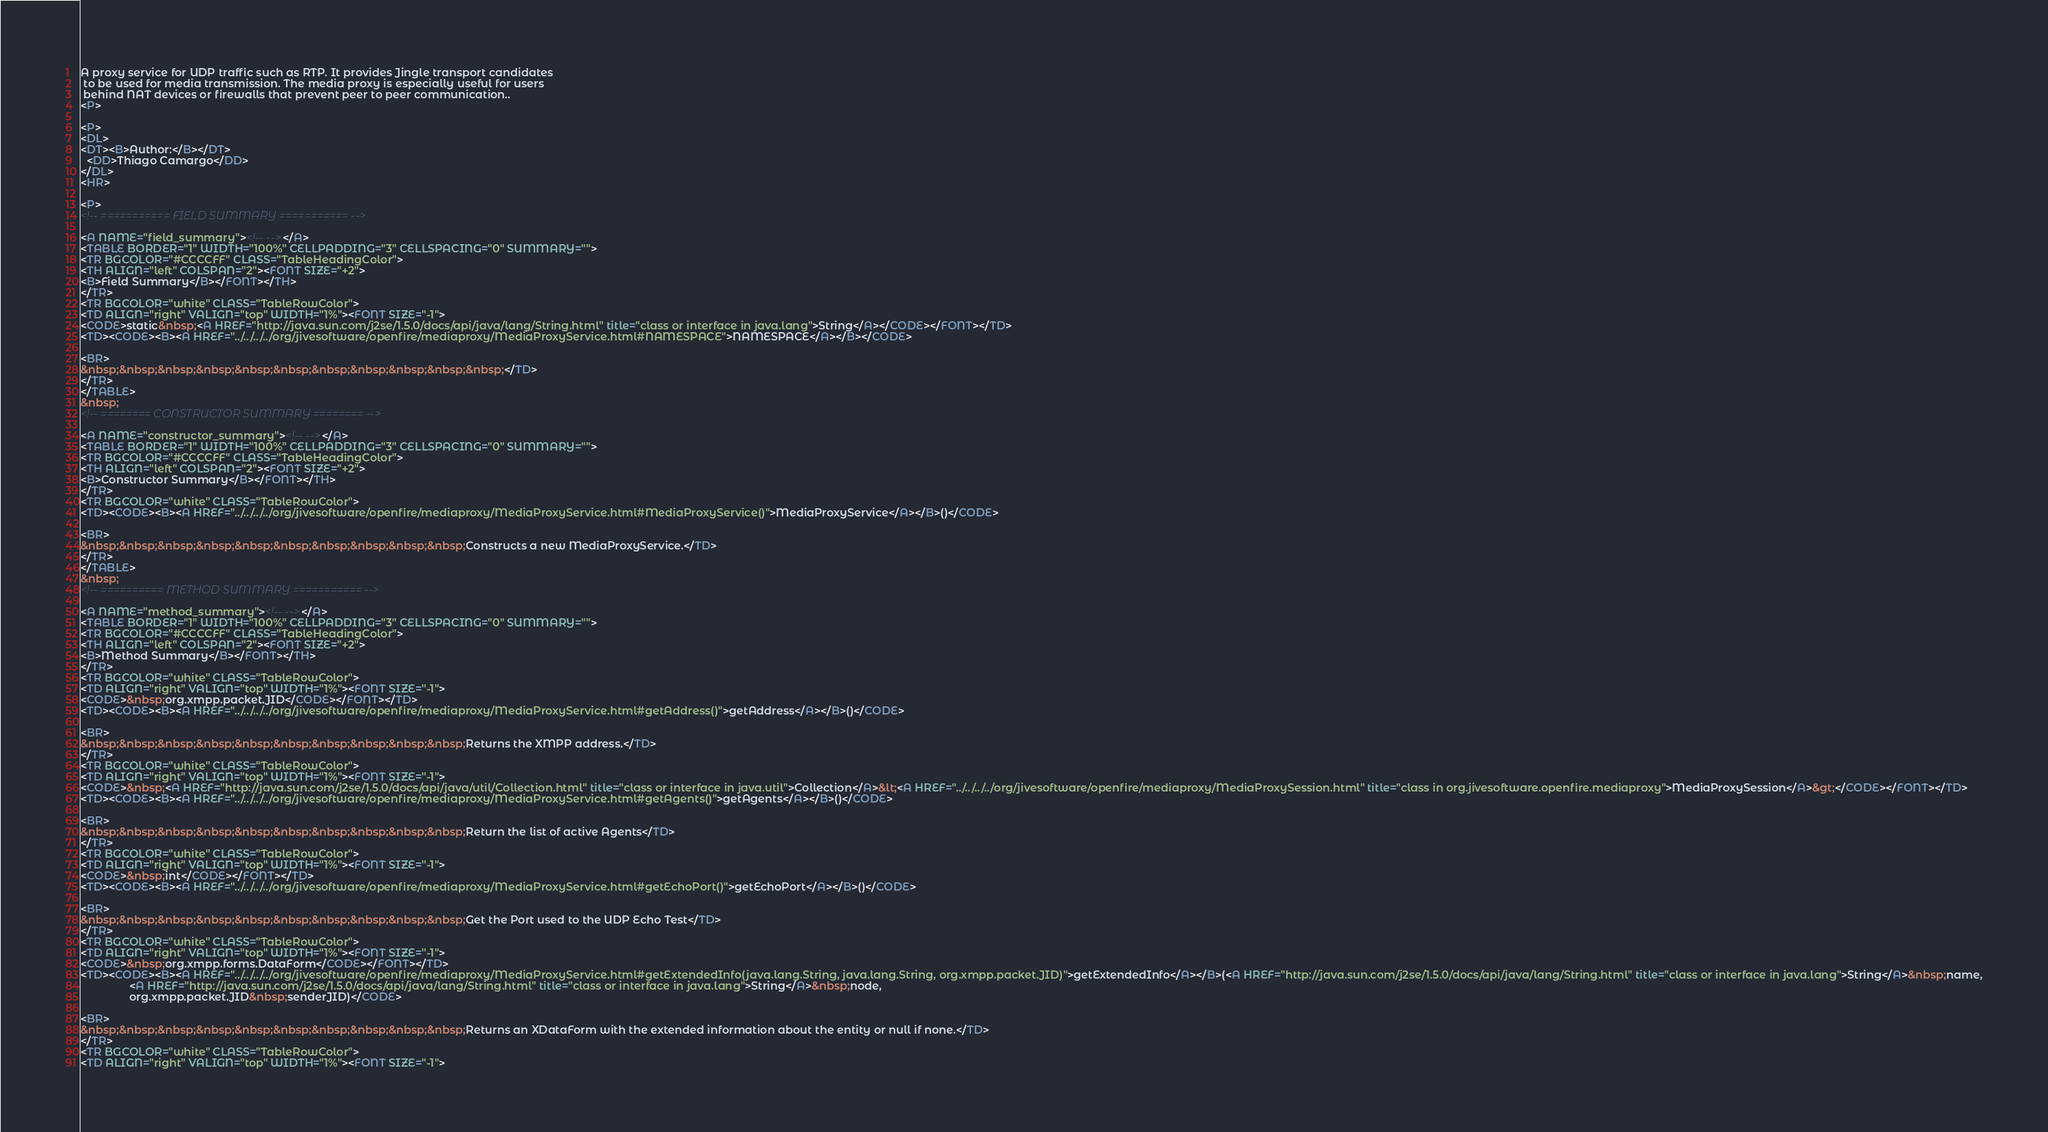Convert code to text. <code><loc_0><loc_0><loc_500><loc_500><_HTML_>A proxy service for UDP traffic such as RTP. It provides Jingle transport candidates
 to be used for media transmission. The media proxy is especially useful for users
 behind NAT devices or firewalls that prevent peer to peer communication..
<P>

<P>
<DL>
<DT><B>Author:</B></DT>
  <DD>Thiago Camargo</DD>
</DL>
<HR>

<P>
<!-- =========== FIELD SUMMARY =========== -->

<A NAME="field_summary"><!-- --></A>
<TABLE BORDER="1" WIDTH="100%" CELLPADDING="3" CELLSPACING="0" SUMMARY="">
<TR BGCOLOR="#CCCCFF" CLASS="TableHeadingColor">
<TH ALIGN="left" COLSPAN="2"><FONT SIZE="+2">
<B>Field Summary</B></FONT></TH>
</TR>
<TR BGCOLOR="white" CLASS="TableRowColor">
<TD ALIGN="right" VALIGN="top" WIDTH="1%"><FONT SIZE="-1">
<CODE>static&nbsp;<A HREF="http://java.sun.com/j2se/1.5.0/docs/api/java/lang/String.html" title="class or interface in java.lang">String</A></CODE></FONT></TD>
<TD><CODE><B><A HREF="../../../../org/jivesoftware/openfire/mediaproxy/MediaProxyService.html#NAMESPACE">NAMESPACE</A></B></CODE>

<BR>
&nbsp;&nbsp;&nbsp;&nbsp;&nbsp;&nbsp;&nbsp;&nbsp;&nbsp;&nbsp;&nbsp;</TD>
</TR>
</TABLE>
&nbsp;
<!-- ======== CONSTRUCTOR SUMMARY ======== -->

<A NAME="constructor_summary"><!-- --></A>
<TABLE BORDER="1" WIDTH="100%" CELLPADDING="3" CELLSPACING="0" SUMMARY="">
<TR BGCOLOR="#CCCCFF" CLASS="TableHeadingColor">
<TH ALIGN="left" COLSPAN="2"><FONT SIZE="+2">
<B>Constructor Summary</B></FONT></TH>
</TR>
<TR BGCOLOR="white" CLASS="TableRowColor">
<TD><CODE><B><A HREF="../../../../org/jivesoftware/openfire/mediaproxy/MediaProxyService.html#MediaProxyService()">MediaProxyService</A></B>()</CODE>

<BR>
&nbsp;&nbsp;&nbsp;&nbsp;&nbsp;&nbsp;&nbsp;&nbsp;&nbsp;&nbsp;Constructs a new MediaProxyService.</TD>
</TR>
</TABLE>
&nbsp;
<!-- ========== METHOD SUMMARY =========== -->

<A NAME="method_summary"><!-- --></A>
<TABLE BORDER="1" WIDTH="100%" CELLPADDING="3" CELLSPACING="0" SUMMARY="">
<TR BGCOLOR="#CCCCFF" CLASS="TableHeadingColor">
<TH ALIGN="left" COLSPAN="2"><FONT SIZE="+2">
<B>Method Summary</B></FONT></TH>
</TR>
<TR BGCOLOR="white" CLASS="TableRowColor">
<TD ALIGN="right" VALIGN="top" WIDTH="1%"><FONT SIZE="-1">
<CODE>&nbsp;org.xmpp.packet.JID</CODE></FONT></TD>
<TD><CODE><B><A HREF="../../../../org/jivesoftware/openfire/mediaproxy/MediaProxyService.html#getAddress()">getAddress</A></B>()</CODE>

<BR>
&nbsp;&nbsp;&nbsp;&nbsp;&nbsp;&nbsp;&nbsp;&nbsp;&nbsp;&nbsp;Returns the XMPP address.</TD>
</TR>
<TR BGCOLOR="white" CLASS="TableRowColor">
<TD ALIGN="right" VALIGN="top" WIDTH="1%"><FONT SIZE="-1">
<CODE>&nbsp;<A HREF="http://java.sun.com/j2se/1.5.0/docs/api/java/util/Collection.html" title="class or interface in java.util">Collection</A>&lt;<A HREF="../../../../org/jivesoftware/openfire/mediaproxy/MediaProxySession.html" title="class in org.jivesoftware.openfire.mediaproxy">MediaProxySession</A>&gt;</CODE></FONT></TD>
<TD><CODE><B><A HREF="../../../../org/jivesoftware/openfire/mediaproxy/MediaProxyService.html#getAgents()">getAgents</A></B>()</CODE>

<BR>
&nbsp;&nbsp;&nbsp;&nbsp;&nbsp;&nbsp;&nbsp;&nbsp;&nbsp;&nbsp;Return the list of active Agents</TD>
</TR>
<TR BGCOLOR="white" CLASS="TableRowColor">
<TD ALIGN="right" VALIGN="top" WIDTH="1%"><FONT SIZE="-1">
<CODE>&nbsp;int</CODE></FONT></TD>
<TD><CODE><B><A HREF="../../../../org/jivesoftware/openfire/mediaproxy/MediaProxyService.html#getEchoPort()">getEchoPort</A></B>()</CODE>

<BR>
&nbsp;&nbsp;&nbsp;&nbsp;&nbsp;&nbsp;&nbsp;&nbsp;&nbsp;&nbsp;Get the Port used to the UDP Echo Test</TD>
</TR>
<TR BGCOLOR="white" CLASS="TableRowColor">
<TD ALIGN="right" VALIGN="top" WIDTH="1%"><FONT SIZE="-1">
<CODE>&nbsp;org.xmpp.forms.DataForm</CODE></FONT></TD>
<TD><CODE><B><A HREF="../../../../org/jivesoftware/openfire/mediaproxy/MediaProxyService.html#getExtendedInfo(java.lang.String, java.lang.String, org.xmpp.packet.JID)">getExtendedInfo</A></B>(<A HREF="http://java.sun.com/j2se/1.5.0/docs/api/java/lang/String.html" title="class or interface in java.lang">String</A>&nbsp;name,
                <A HREF="http://java.sun.com/j2se/1.5.0/docs/api/java/lang/String.html" title="class or interface in java.lang">String</A>&nbsp;node,
                org.xmpp.packet.JID&nbsp;senderJID)</CODE>

<BR>
&nbsp;&nbsp;&nbsp;&nbsp;&nbsp;&nbsp;&nbsp;&nbsp;&nbsp;&nbsp;Returns an XDataForm with the extended information about the entity or null if none.</TD>
</TR>
<TR BGCOLOR="white" CLASS="TableRowColor">
<TD ALIGN="right" VALIGN="top" WIDTH="1%"><FONT SIZE="-1"></code> 